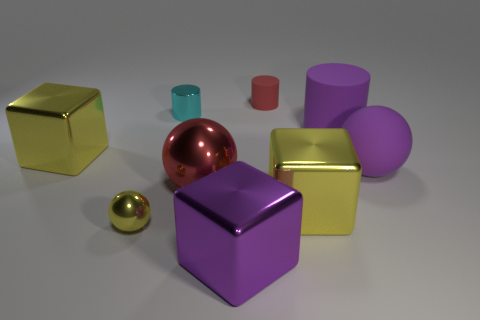Is the matte sphere the same color as the large cylinder?
Give a very brief answer. Yes. The rubber cylinder that is the same color as the large rubber sphere is what size?
Your answer should be very brief. Large. Are there any large shiny balls that have the same color as the tiny matte cylinder?
Your response must be concise. Yes. Does the small shiny sphere have the same color as the shiny object that is right of the small matte object?
Offer a very short reply. Yes. What number of things are either big yellow blocks that are in front of the large metal sphere or metal balls to the right of the cyan cylinder?
Offer a very short reply. 2. There is a big shiny object that is to the right of the purple object that is in front of the tiny metallic ball; what shape is it?
Make the answer very short. Cube. Is there a big yellow cube that has the same material as the tiny yellow object?
Your answer should be compact. Yes. The other rubber object that is the same shape as the small yellow object is what color?
Offer a very short reply. Purple. Is the number of big metallic cubes on the right side of the large purple cylinder less than the number of yellow shiny objects behind the red sphere?
Make the answer very short. Yes. How many other objects are there of the same shape as the tiny yellow shiny thing?
Make the answer very short. 2. 